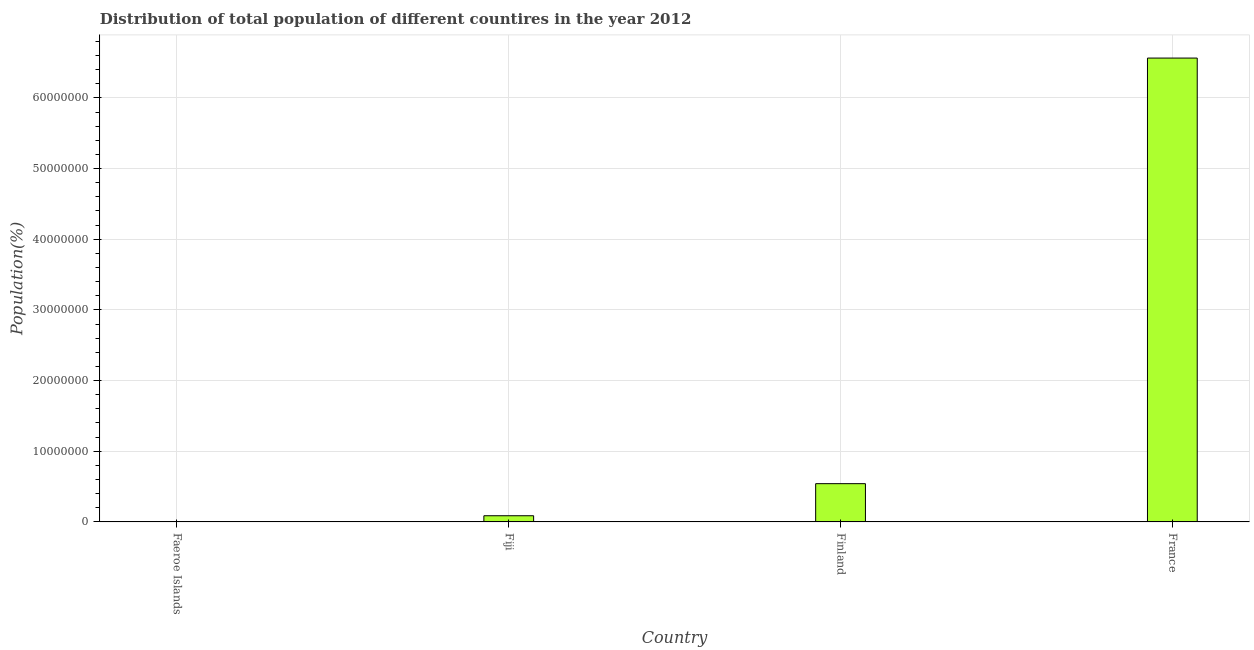Does the graph contain any zero values?
Ensure brevity in your answer.  No. Does the graph contain grids?
Your answer should be compact. Yes. What is the title of the graph?
Offer a very short reply. Distribution of total population of different countires in the year 2012. What is the label or title of the X-axis?
Your answer should be very brief. Country. What is the label or title of the Y-axis?
Give a very brief answer. Population(%). What is the population in Faeroe Islands?
Keep it short and to the point. 4.84e+04. Across all countries, what is the maximum population?
Your response must be concise. 6.56e+07. Across all countries, what is the minimum population?
Make the answer very short. 4.84e+04. In which country was the population minimum?
Keep it short and to the point. Faeroe Islands. What is the sum of the population?
Provide a short and direct response. 7.20e+07. What is the difference between the population in Fiji and Finland?
Provide a short and direct response. -4.54e+06. What is the average population per country?
Your answer should be compact. 1.80e+07. What is the median population?
Your response must be concise. 3.14e+06. What is the ratio of the population in Faeroe Islands to that in Finland?
Your response must be concise. 0.01. Is the difference between the population in Faeroe Islands and France greater than the difference between any two countries?
Ensure brevity in your answer.  Yes. What is the difference between the highest and the second highest population?
Offer a terse response. 6.02e+07. Is the sum of the population in Finland and France greater than the maximum population across all countries?
Provide a short and direct response. Yes. What is the difference between the highest and the lowest population?
Offer a very short reply. 6.56e+07. In how many countries, is the population greater than the average population taken over all countries?
Give a very brief answer. 1. Are all the bars in the graph horizontal?
Your answer should be compact. No. How many countries are there in the graph?
Provide a succinct answer. 4. What is the difference between two consecutive major ticks on the Y-axis?
Provide a short and direct response. 1.00e+07. Are the values on the major ticks of Y-axis written in scientific E-notation?
Your response must be concise. No. What is the Population(%) in Faeroe Islands?
Give a very brief answer. 4.84e+04. What is the Population(%) of Fiji?
Your answer should be very brief. 8.74e+05. What is the Population(%) of Finland?
Provide a succinct answer. 5.41e+06. What is the Population(%) in France?
Your response must be concise. 6.56e+07. What is the difference between the Population(%) in Faeroe Islands and Fiji?
Ensure brevity in your answer.  -8.26e+05. What is the difference between the Population(%) in Faeroe Islands and Finland?
Your response must be concise. -5.37e+06. What is the difference between the Population(%) in Faeroe Islands and France?
Make the answer very short. -6.56e+07. What is the difference between the Population(%) in Fiji and Finland?
Give a very brief answer. -4.54e+06. What is the difference between the Population(%) in Fiji and France?
Give a very brief answer. -6.48e+07. What is the difference between the Population(%) in Finland and France?
Provide a succinct answer. -6.02e+07. What is the ratio of the Population(%) in Faeroe Islands to that in Fiji?
Provide a short and direct response. 0.06. What is the ratio of the Population(%) in Faeroe Islands to that in Finland?
Your answer should be very brief. 0.01. What is the ratio of the Population(%) in Fiji to that in Finland?
Offer a terse response. 0.16. What is the ratio of the Population(%) in Fiji to that in France?
Your answer should be very brief. 0.01. What is the ratio of the Population(%) in Finland to that in France?
Provide a succinct answer. 0.08. 